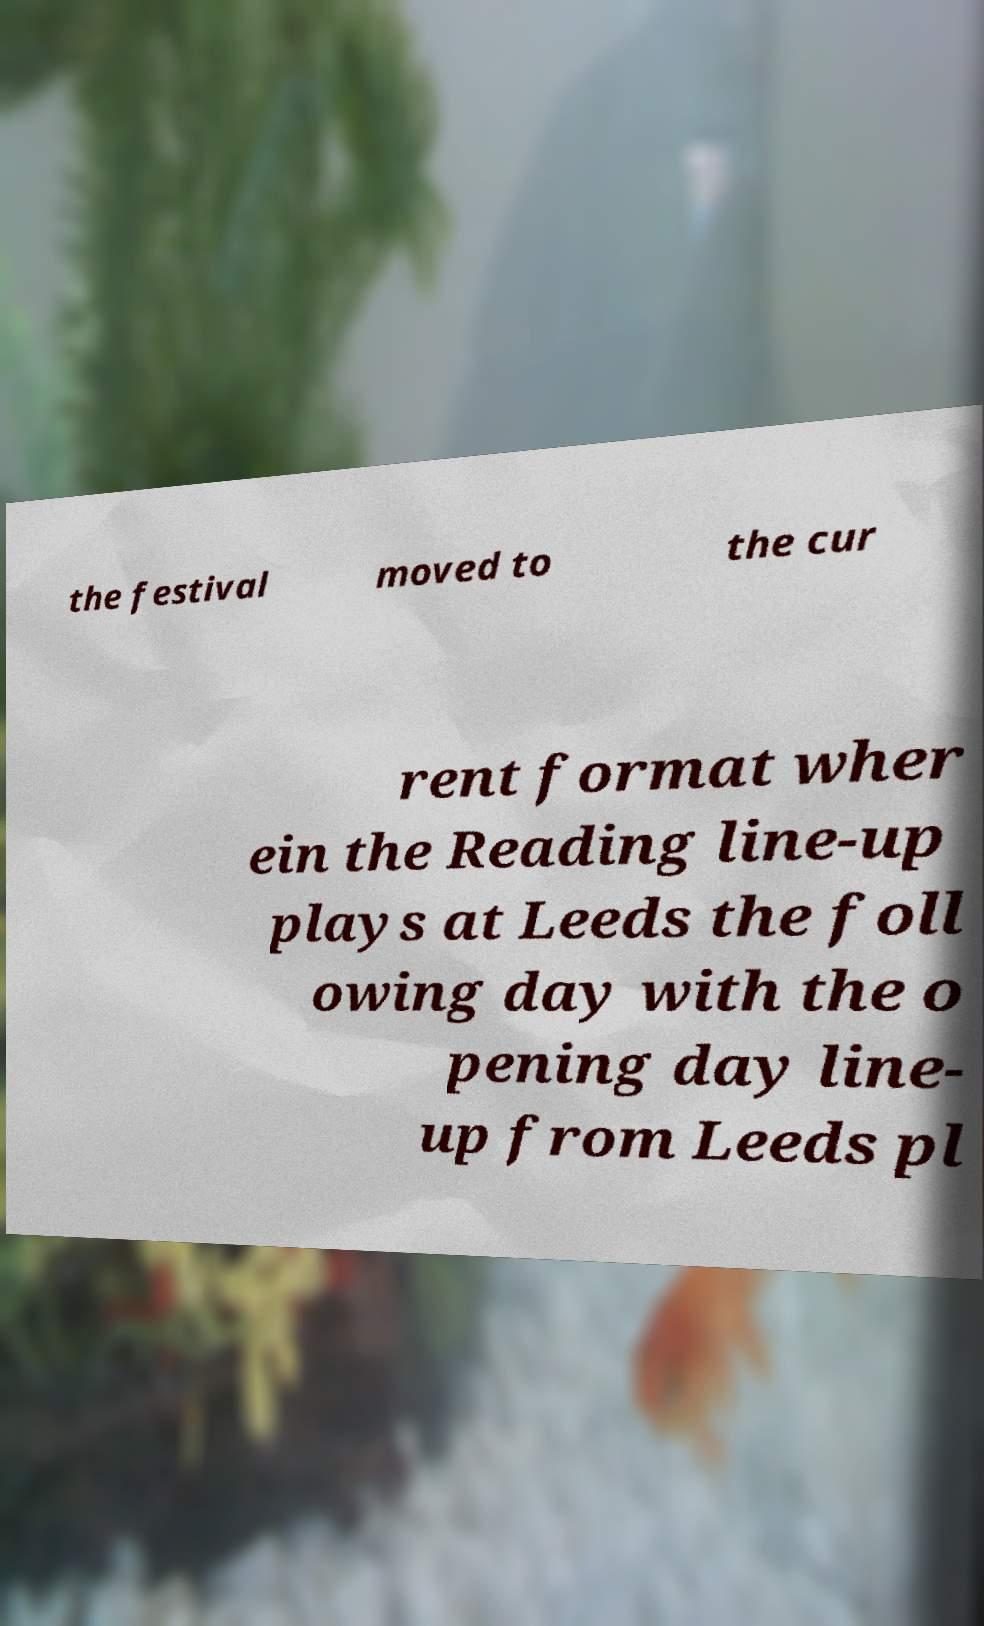Can you accurately transcribe the text from the provided image for me? the festival moved to the cur rent format wher ein the Reading line-up plays at Leeds the foll owing day with the o pening day line- up from Leeds pl 